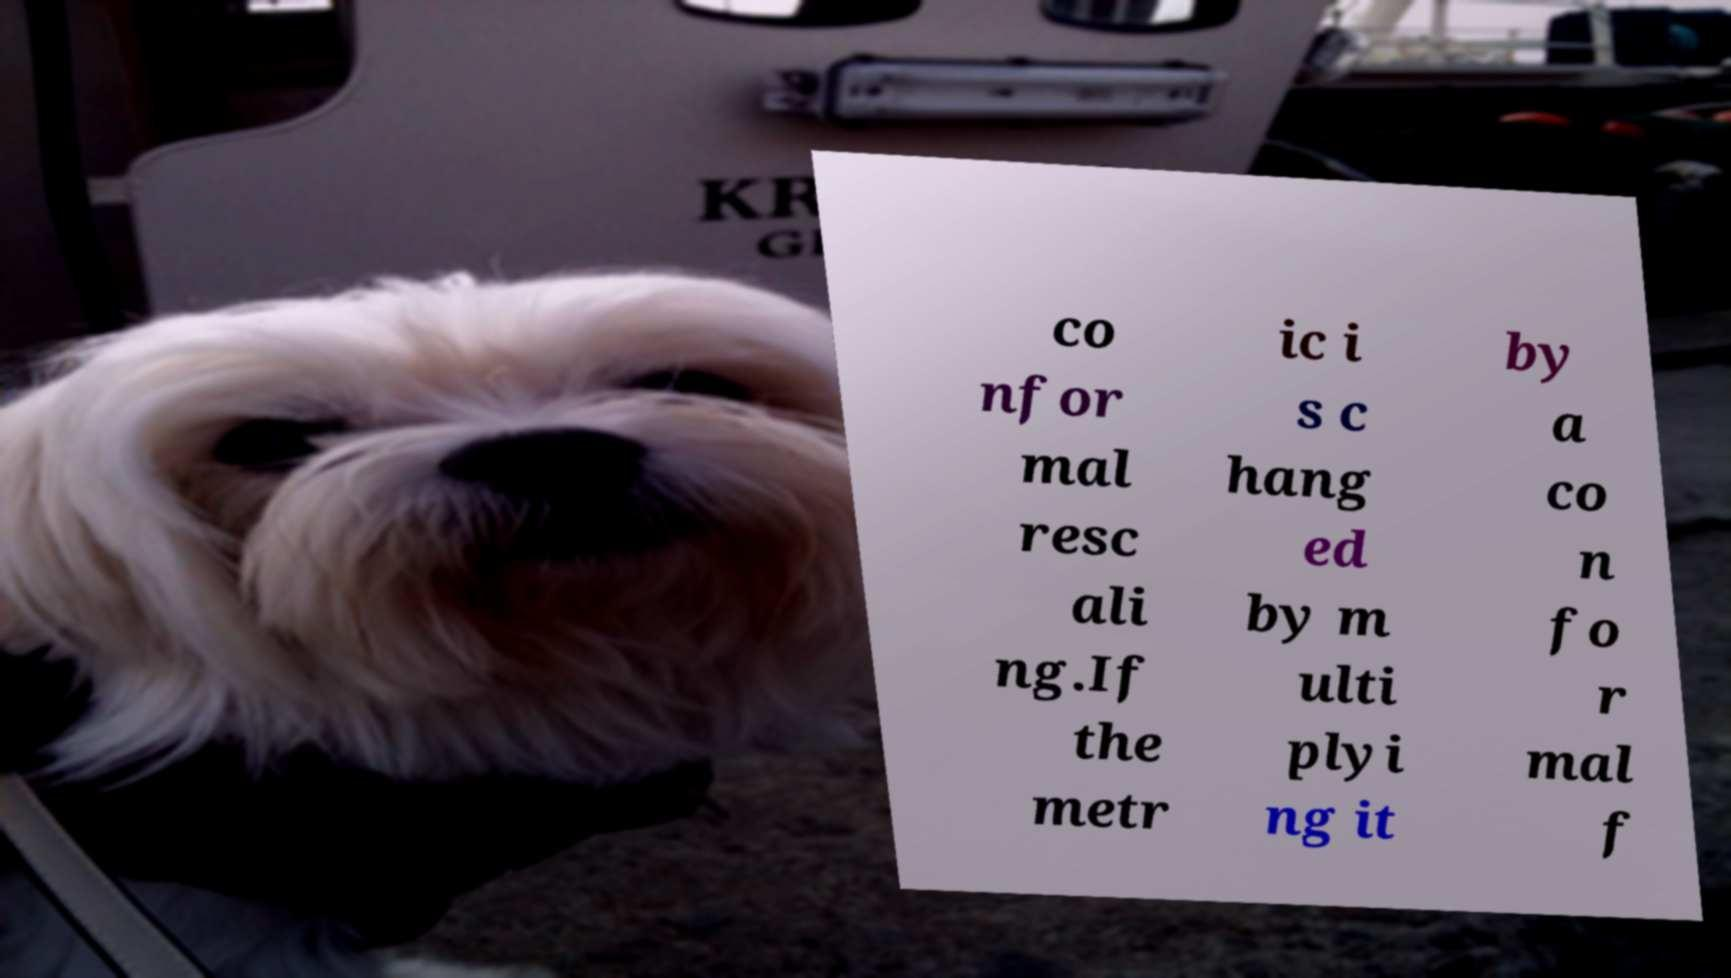Can you read and provide the text displayed in the image?This photo seems to have some interesting text. Can you extract and type it out for me? co nfor mal resc ali ng.If the metr ic i s c hang ed by m ulti plyi ng it by a co n fo r mal f 